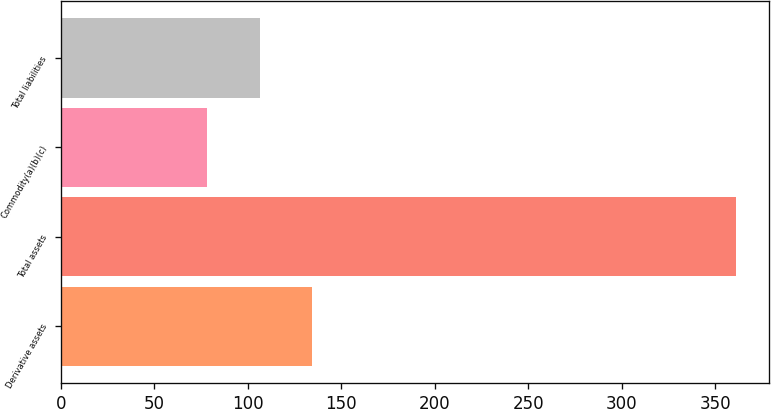Convert chart. <chart><loc_0><loc_0><loc_500><loc_500><bar_chart><fcel>Derivative assets<fcel>Total assets<fcel>Commodity(a)(b)(c)<fcel>Total liabilities<nl><fcel>134.6<fcel>361<fcel>78<fcel>106.3<nl></chart> 